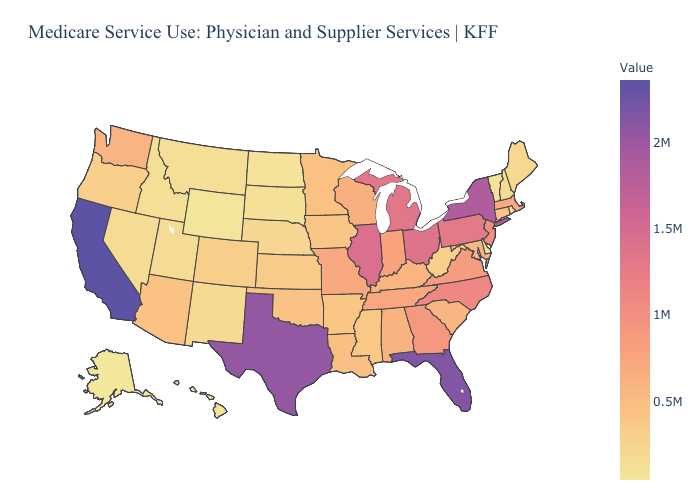Which states have the lowest value in the USA?
Short answer required. Alaska. Which states have the lowest value in the USA?
Keep it brief. Alaska. 